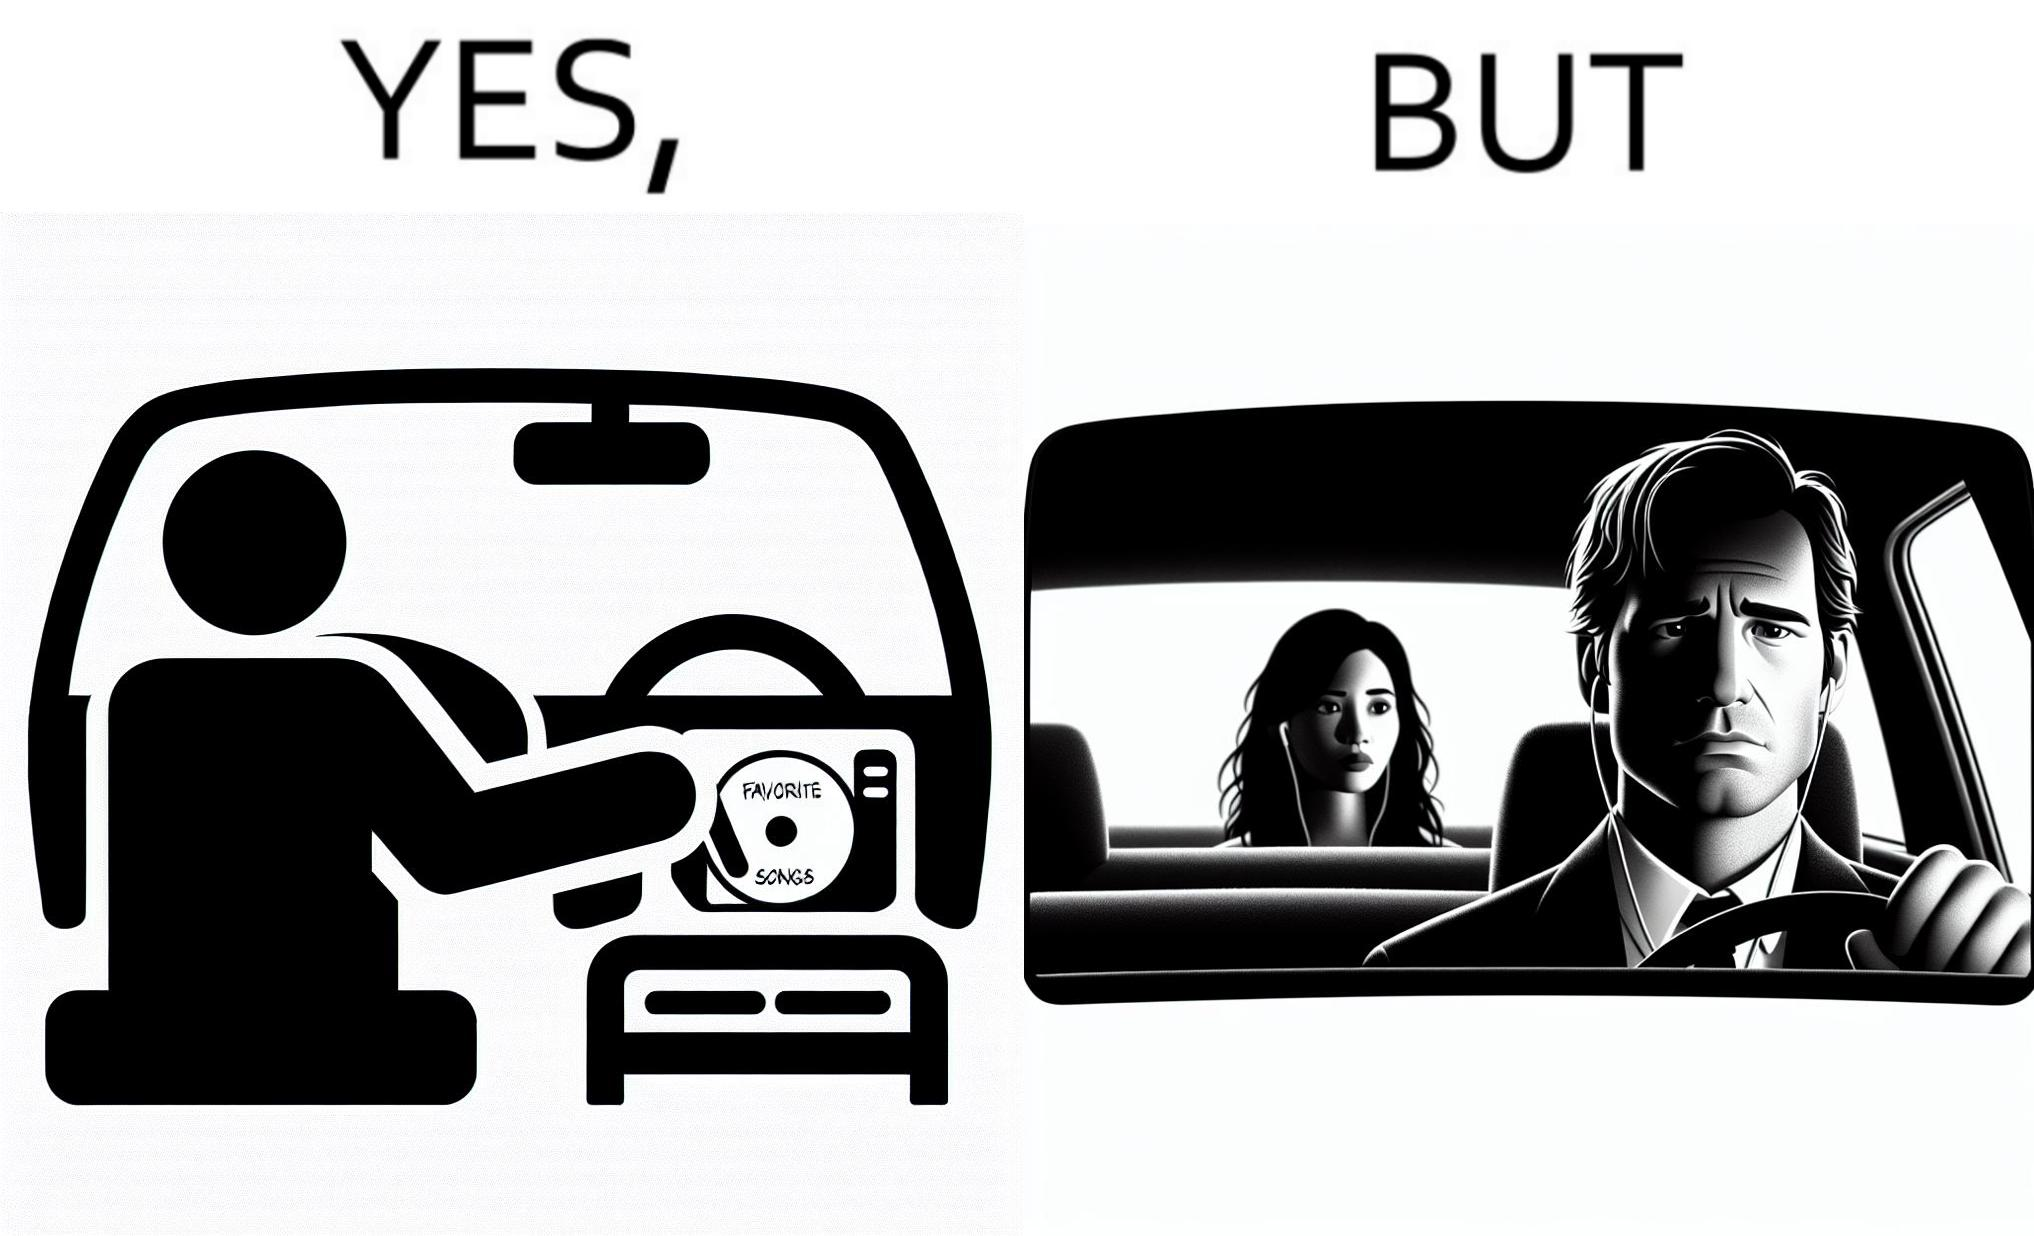Does this image contain satire or humor? Yes, this image is satirical. 